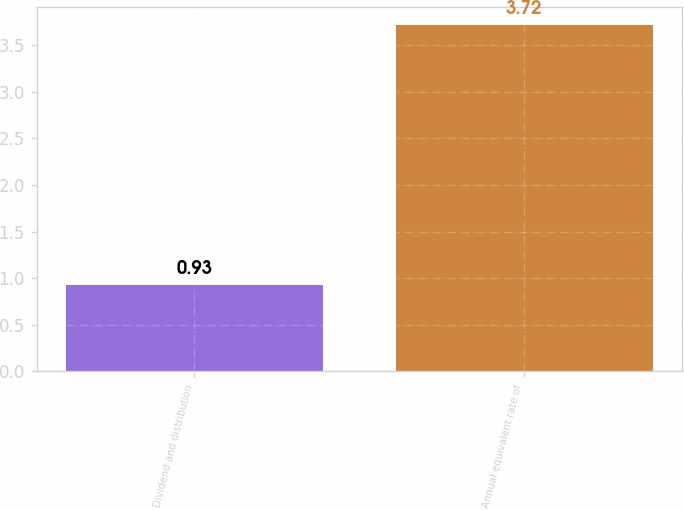<chart> <loc_0><loc_0><loc_500><loc_500><bar_chart><fcel>Dividend and distribution<fcel>Annual equivalent rate of<nl><fcel>0.93<fcel>3.72<nl></chart> 